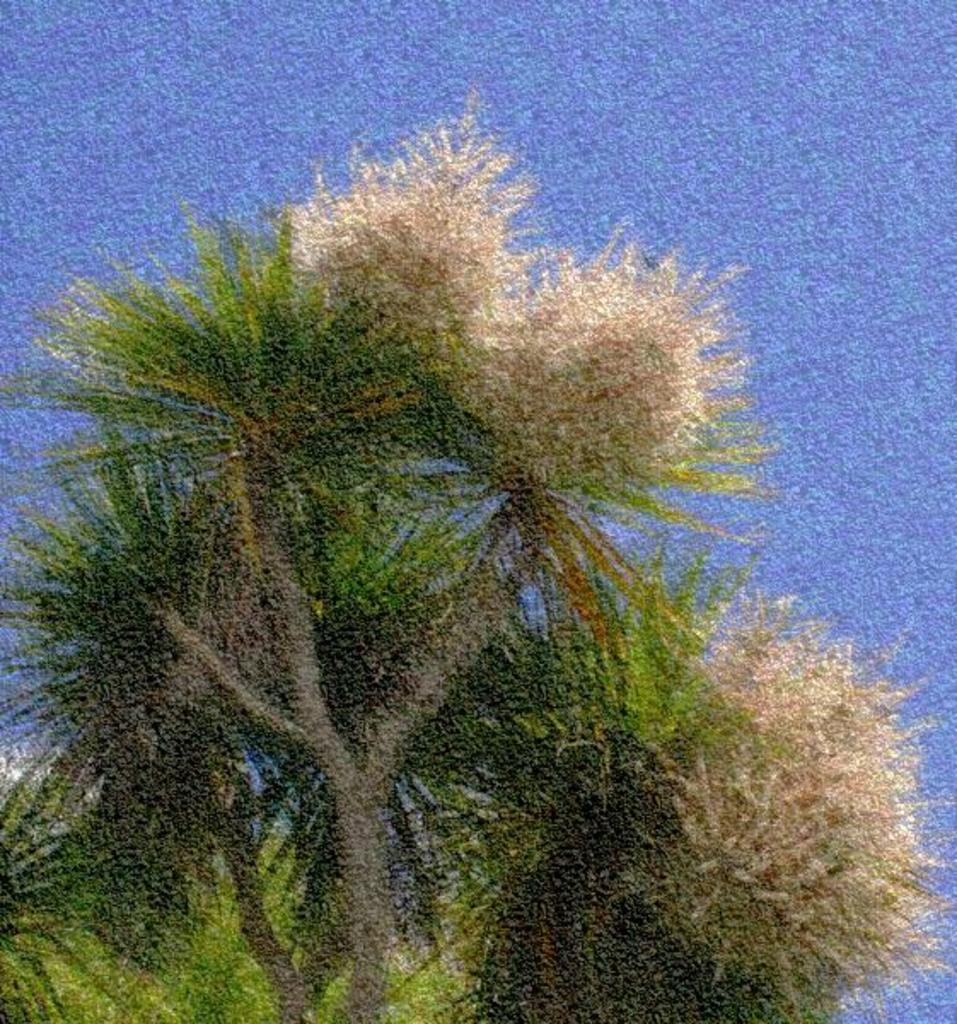How would you summarize this image in a sentence or two? Here we can see a tree. Background it is in blue color. 